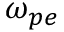<formula> <loc_0><loc_0><loc_500><loc_500>\omega _ { p e }</formula> 